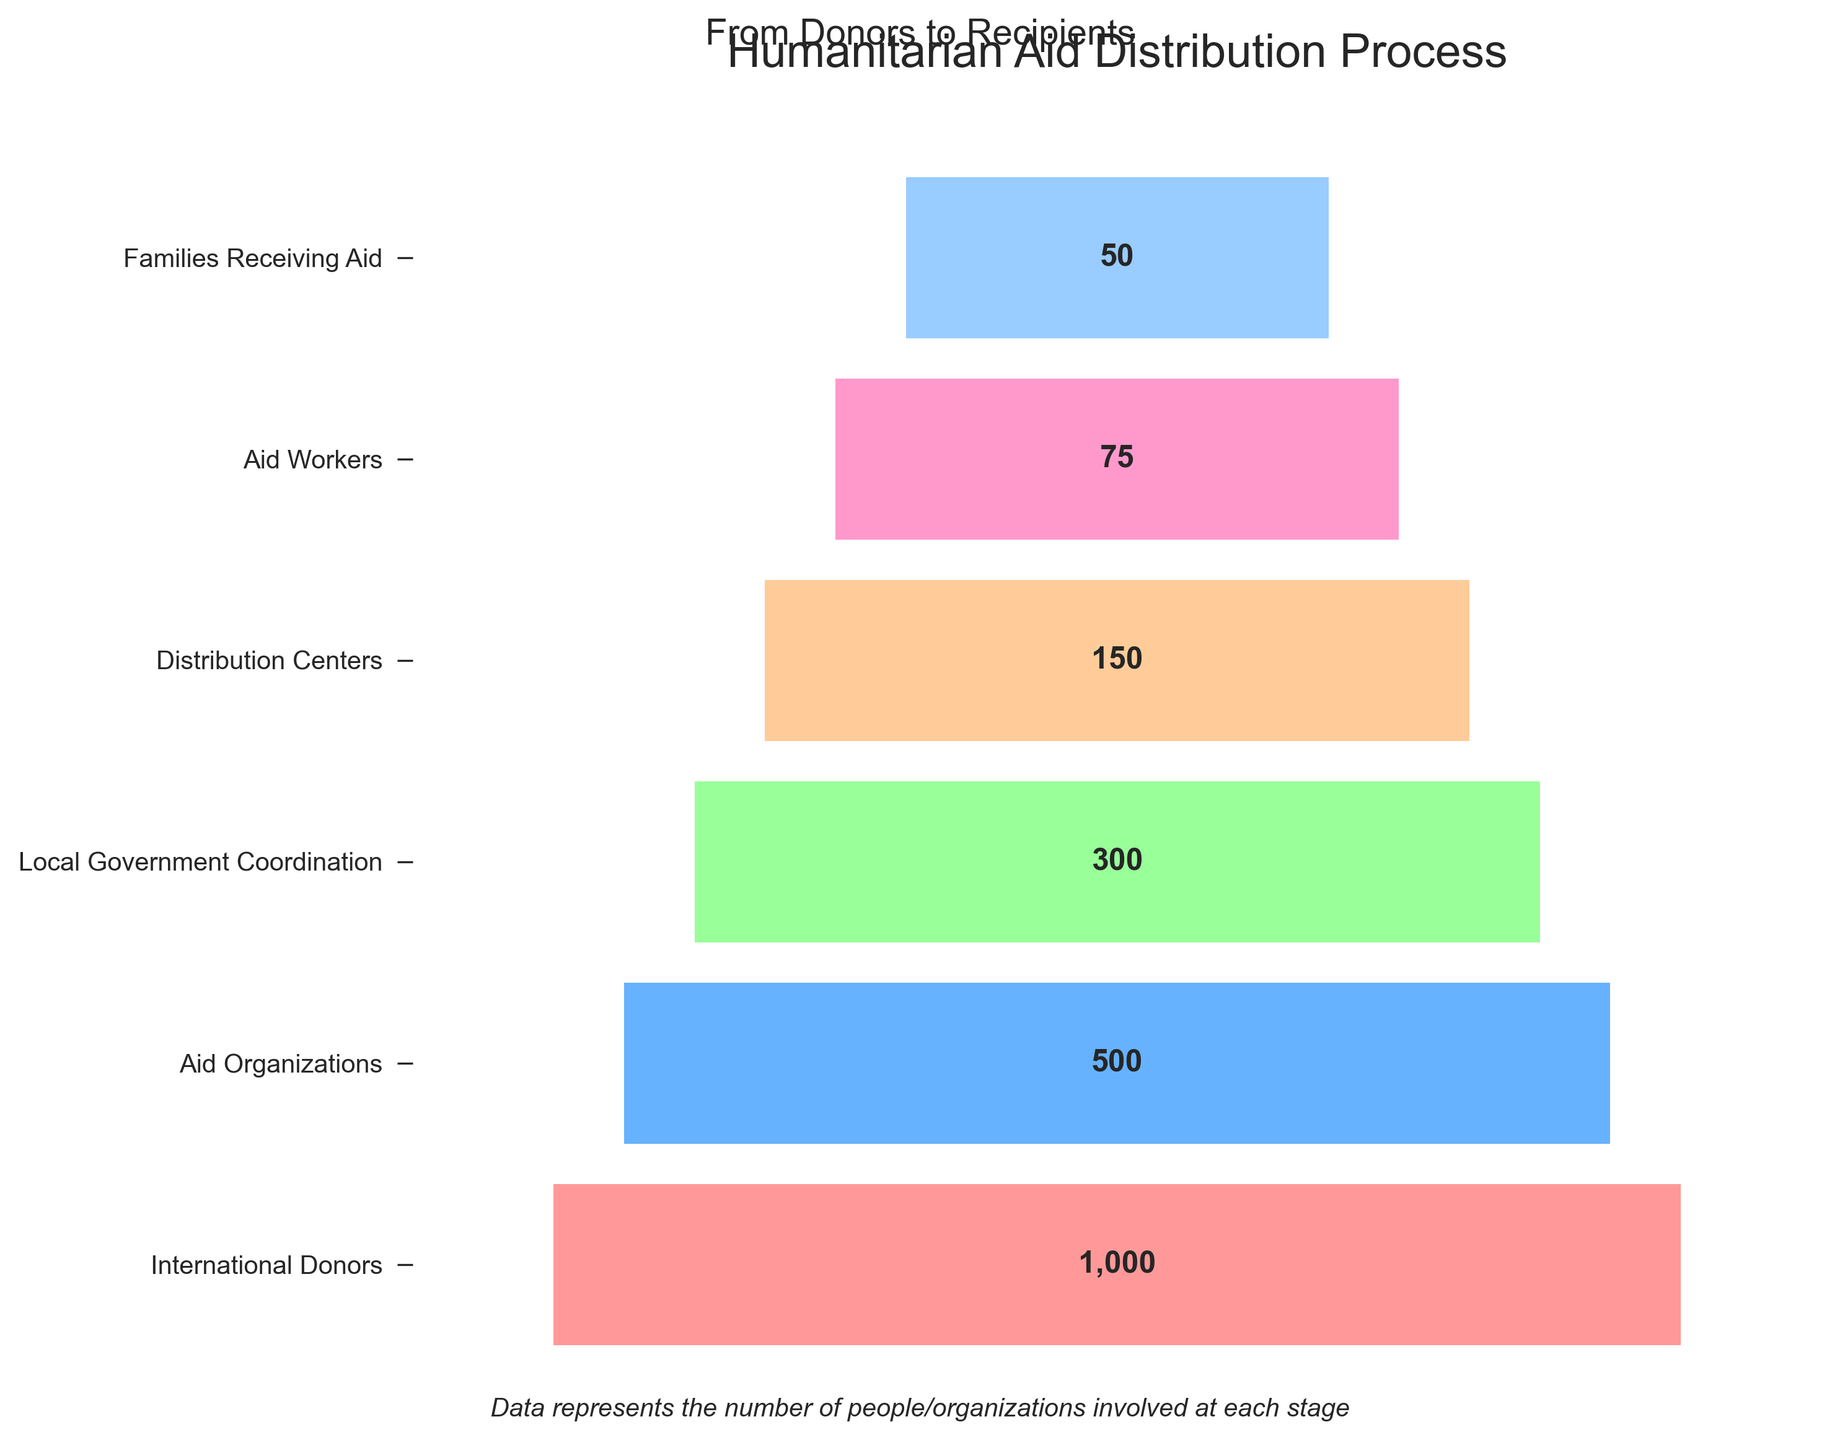What is the title of the funnel chart? The title is written at the top of the chart and provides an overview of what the chart is about.
Answer: Humanitarian Aid Distribution Process What stage has the highest number of people/organizations involved? The first bar in the funnel chart is the widest, indicating the highest number of people/organizations. The label associated with it helps identify the stage.
Answer: International Donors What stage has the second-lowest number of people/organizations involved? The funnel chart narrows down from the top. The second narrowest bar from the bottom represents the second-lowest number of people/organizations.
Answer: Aid Workers How many more people/organizations are involved at the International Donors stage compared to the Families Receiving Aid stage? The values associated with both stages are given. Subtract the value for Families Receiving Aid from the value for International Donors.
Answer: 950 Which stage has exactly twice the number of people/organizations as the Distribution Centers stage? Multiply the value for Distribution Centers by 2 and find the stage that matches this new value.
Answer: Local Government Coordination Is the number of people/organizations involved at the Distribution Centers stage more than half of those at the Aid Organizations stage? Compare half of the value for Aid Organizations with the value for Distribution Centers.
Answer: No Compare the number of people/organizations between Aid Organizations and Local Government Coordination. Which has more, and by how much? Subtract the value for Local Government Coordination from the value for Aid Organizations to find the difference.
Answer: Aid Organizations, by 200 If the aid were redistributed evenly at the Distribution Centers stage, how many more people/organizations would each Aid Worker be responsible for compared to at the Families Receiving Aid stage? Divide the value for Distribution Centers by the value for Aid Workers, then divide the value for Families Receiving Aid by the same, and find the difference.
Answer: 1 How does the number of people/organizations change as aid moves from Donors to Recipients? Observe the funnel shape and note how the width of the bars (representing the number of people/organizations) decreases from top to bottom.
Answer: Decreases Which stage involves three times as many people/organizations as the Families Receiving Aid stage? Multiply the value for Families Receiving Aid by 3 and find the matching stage.
Answer: Distribution Centers 